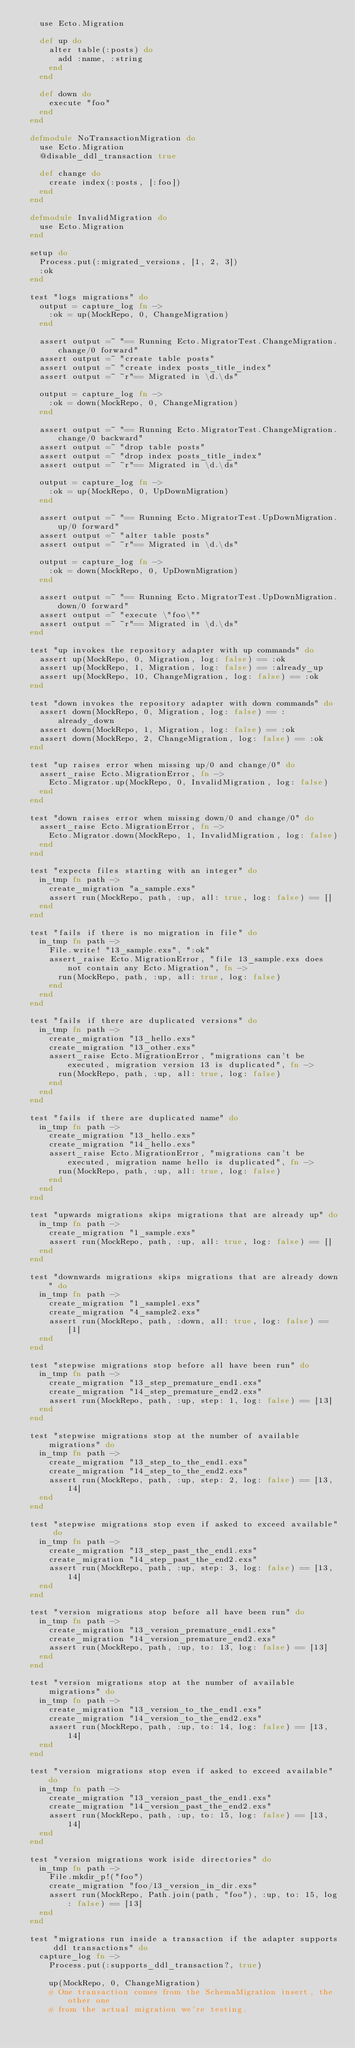Convert code to text. <code><loc_0><loc_0><loc_500><loc_500><_Elixir_>    use Ecto.Migration

    def up do
      alter table(:posts) do
        add :name, :string
      end
    end

    def down do
      execute "foo"
    end
  end

  defmodule NoTransactionMigration do
    use Ecto.Migration
    @disable_ddl_transaction true

    def change do
      create index(:posts, [:foo])
    end
  end

  defmodule InvalidMigration do
    use Ecto.Migration
  end

  setup do
    Process.put(:migrated_versions, [1, 2, 3])
    :ok
  end

  test "logs migrations" do
    output = capture_log fn ->
      :ok = up(MockRepo, 0, ChangeMigration)
    end

    assert output =~ "== Running Ecto.MigratorTest.ChangeMigration.change/0 forward"
    assert output =~ "create table posts"
    assert output =~ "create index posts_title_index"
    assert output =~ ~r"== Migrated in \d.\ds"

    output = capture_log fn ->
      :ok = down(MockRepo, 0, ChangeMigration)
    end

    assert output =~ "== Running Ecto.MigratorTest.ChangeMigration.change/0 backward"
    assert output =~ "drop table posts"
    assert output =~ "drop index posts_title_index"
    assert output =~ ~r"== Migrated in \d.\ds"

    output = capture_log fn ->
      :ok = up(MockRepo, 0, UpDownMigration)
    end

    assert output =~ "== Running Ecto.MigratorTest.UpDownMigration.up/0 forward"
    assert output =~ "alter table posts"
    assert output =~ ~r"== Migrated in \d.\ds"

    output = capture_log fn ->
      :ok = down(MockRepo, 0, UpDownMigration)
    end

    assert output =~ "== Running Ecto.MigratorTest.UpDownMigration.down/0 forward"
    assert output =~ "execute \"foo\""
    assert output =~ ~r"== Migrated in \d.\ds"
  end

  test "up invokes the repository adapter with up commands" do
    assert up(MockRepo, 0, Migration, log: false) == :ok
    assert up(MockRepo, 1, Migration, log: false) == :already_up
    assert up(MockRepo, 10, ChangeMigration, log: false) == :ok
  end

  test "down invokes the repository adapter with down commands" do
    assert down(MockRepo, 0, Migration, log: false) == :already_down
    assert down(MockRepo, 1, Migration, log: false) == :ok
    assert down(MockRepo, 2, ChangeMigration, log: false) == :ok
  end

  test "up raises error when missing up/0 and change/0" do
    assert_raise Ecto.MigrationError, fn ->
      Ecto.Migrator.up(MockRepo, 0, InvalidMigration, log: false)
    end
  end

  test "down raises error when missing down/0 and change/0" do
    assert_raise Ecto.MigrationError, fn ->
      Ecto.Migrator.down(MockRepo, 1, InvalidMigration, log: false)
    end
  end

  test "expects files starting with an integer" do
    in_tmp fn path ->
      create_migration "a_sample.exs"
      assert run(MockRepo, path, :up, all: true, log: false) == []
    end
  end

  test "fails if there is no migration in file" do
    in_tmp fn path ->
      File.write! "13_sample.exs", ":ok"
      assert_raise Ecto.MigrationError, "file 13_sample.exs does not contain any Ecto.Migration", fn ->
        run(MockRepo, path, :up, all: true, log: false)
      end
    end
  end

  test "fails if there are duplicated versions" do
    in_tmp fn path ->
      create_migration "13_hello.exs"
      create_migration "13_other.exs"
      assert_raise Ecto.MigrationError, "migrations can't be executed, migration version 13 is duplicated", fn ->
        run(MockRepo, path, :up, all: true, log: false)
      end
    end
  end

  test "fails if there are duplicated name" do
    in_tmp fn path ->
      create_migration "13_hello.exs"
      create_migration "14_hello.exs"
      assert_raise Ecto.MigrationError, "migrations can't be executed, migration name hello is duplicated", fn ->
        run(MockRepo, path, :up, all: true, log: false)
      end
    end
  end

  test "upwards migrations skips migrations that are already up" do
    in_tmp fn path ->
      create_migration "1_sample.exs"
      assert run(MockRepo, path, :up, all: true, log: false) == []
    end
  end

  test "downwards migrations skips migrations that are already down" do
    in_tmp fn path ->
      create_migration "1_sample1.exs"
      create_migration "4_sample2.exs"
      assert run(MockRepo, path, :down, all: true, log: false) == [1]
    end
  end

  test "stepwise migrations stop before all have been run" do
    in_tmp fn path ->
      create_migration "13_step_premature_end1.exs"
      create_migration "14_step_premature_end2.exs"
      assert run(MockRepo, path, :up, step: 1, log: false) == [13]
    end
  end

  test "stepwise migrations stop at the number of available migrations" do
    in_tmp fn path ->
      create_migration "13_step_to_the_end1.exs"
      create_migration "14_step_to_the_end2.exs"
      assert run(MockRepo, path, :up, step: 2, log: false) == [13, 14]
    end
  end

  test "stepwise migrations stop even if asked to exceed available" do
    in_tmp fn path ->
      create_migration "13_step_past_the_end1.exs"
      create_migration "14_step_past_the_end2.exs"
      assert run(MockRepo, path, :up, step: 3, log: false) == [13, 14]
    end
  end

  test "version migrations stop before all have been run" do
    in_tmp fn path ->
      create_migration "13_version_premature_end1.exs"
      create_migration "14_version_premature_end2.exs"
      assert run(MockRepo, path, :up, to: 13, log: false) == [13]
    end
  end

  test "version migrations stop at the number of available migrations" do
    in_tmp fn path ->
      create_migration "13_version_to_the_end1.exs"
      create_migration "14_version_to_the_end2.exs"
      assert run(MockRepo, path, :up, to: 14, log: false) == [13, 14]
    end
  end

  test "version migrations stop even if asked to exceed available" do
    in_tmp fn path ->
      create_migration "13_version_past_the_end1.exs"
      create_migration "14_version_past_the_end2.exs"
      assert run(MockRepo, path, :up, to: 15, log: false) == [13, 14]
    end
  end

  test "version migrations work iside directories" do
    in_tmp fn path ->
      File.mkdir_p!("foo")
      create_migration "foo/13_version_in_dir.exs"
      assert run(MockRepo, Path.join(path, "foo"), :up, to: 15, log: false) == [13]
    end
  end

  test "migrations run inside a transaction if the adapter supports ddl transactions" do
    capture_log fn ->
      Process.put(:supports_ddl_transaction?, true)

      up(MockRepo, 0, ChangeMigration)
      # One transaction comes from the SchemaMigration insert, the other one
      # from the actual migration we're testing.</code> 